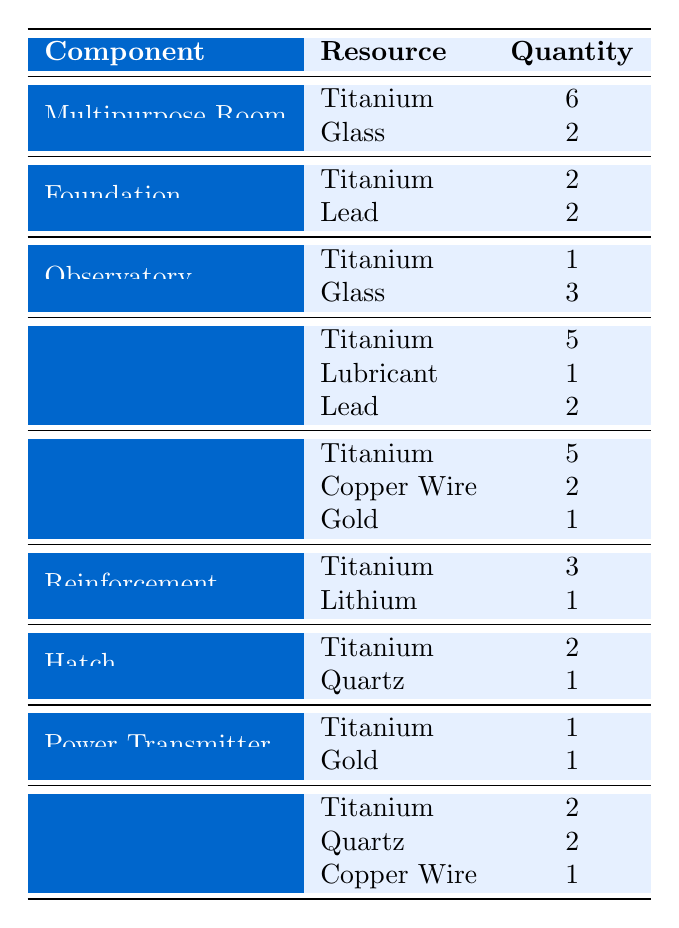What resources are needed to build a Multipurpose Room? The table lists the resources required for building a Multipurpose Room, which are Titanium (6 units) and Glass (2 units).
Answer: Titanium: 6, Glass: 2 How many Titanium are needed for a Foundation? The table indicates that a Foundation requires 2 units of Titanium.
Answer: 2 What is the total quantity of Copper Wire required for constructing a Scanner Room? According to the table, a Scanner Room requires 2 units of Copper Wire. Thus, the total is 2.
Answer: 2 True or False: A Hatch requires more Quartz than Titanium. The table specifies that a Hatch requires 1 unit of Quartz and 2 units of Titanium, making the statement false because 2 is greater than 1.
Answer: False What is the total resource requirement for building a Solar Panel? The table shows the resources needed for a Solar Panel are Titanium (2 units), Quartz (2 units), and Copper Wire (1 unit). Summing these gives 2 + 2 + 1 = 5.
Answer: 5 How many resources does a Moon Pool require in total? To find the total resources for a Moon Pool, add the quantities listed: Titanium (5), Lubricant (1), and Lead (2), which sums up to 5 + 1 + 2 = 8.
Answer: 8 Which base component requires the most Glass? The table shows that the Observatory requires the most Glass, with 3 units needed.
Answer: Observatory What is the average number of Titanium required for the components listed? The table indicates that Titanium is required in varying amounts: 6 (Multipurpose Room), 2 (Foundation), 1 (Observatory), 5 (Moon Pool), 5 (Scanner Room), 3 (Reinforcement), 2 (Hatch), 1 (Power Transmitter), 2 (Solar Panel). In total, that adds up to 27 Titanium for 9 components, so the average is 27 / 9 = 3.
Answer: 3 How many unique components require Gold? The table shows two components that require Gold: the Scanner Room and the Power Transmitter, making a total of 2 unique components.
Answer: 2 What is the difference in the quantity of Titanium required between a Scanner Room and a Moon Pool? The table lists a Scanner Room needs 5 Titanium, while a Moon Pool requires 5 Titanium as well. Thus, the difference is 5 - 5 = 0.
Answer: 0 